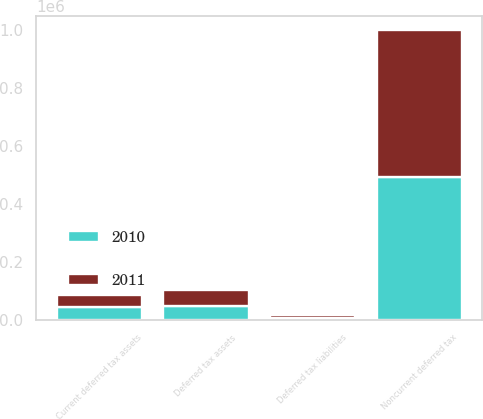<chart> <loc_0><loc_0><loc_500><loc_500><stacked_bar_chart><ecel><fcel>Deferred tax assets<fcel>Deferred tax liabilities<fcel>Current deferred tax assets<fcel>Noncurrent deferred tax<nl><fcel>2010<fcel>49342<fcel>5117<fcel>44225<fcel>492464<nl><fcel>2011<fcel>54383<fcel>11148<fcel>43235<fcel>507358<nl></chart> 